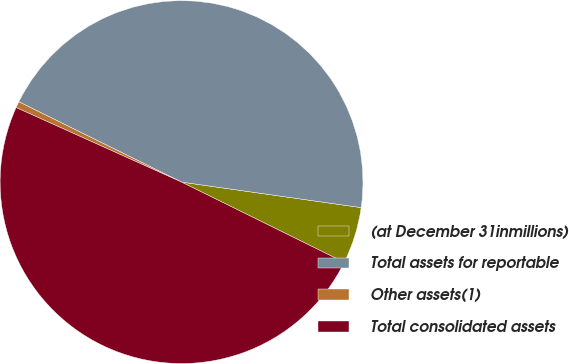Convert chart. <chart><loc_0><loc_0><loc_500><loc_500><pie_chart><fcel>(at December 31inmillions)<fcel>Total assets for reportable<fcel>Other assets(1)<fcel>Total consolidated assets<nl><fcel>5.05%<fcel>44.95%<fcel>0.56%<fcel>49.44%<nl></chart> 